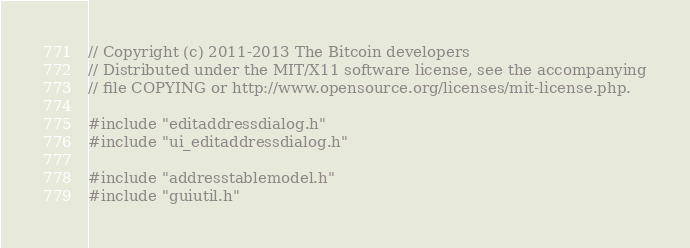Convert code to text. <code><loc_0><loc_0><loc_500><loc_500><_C++_>// Copyright (c) 2011-2013 The Bitcoin developers
// Distributed under the MIT/X11 software license, see the accompanying
// file COPYING or http://www.opensource.org/licenses/mit-license.php.

#include "editaddressdialog.h"
#include "ui_editaddressdialog.h"

#include "addresstablemodel.h"
#include "guiutil.h"
</code> 